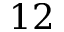<formula> <loc_0><loc_0><loc_500><loc_500>1 2</formula> 